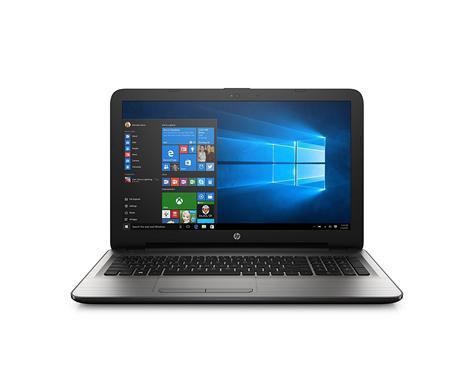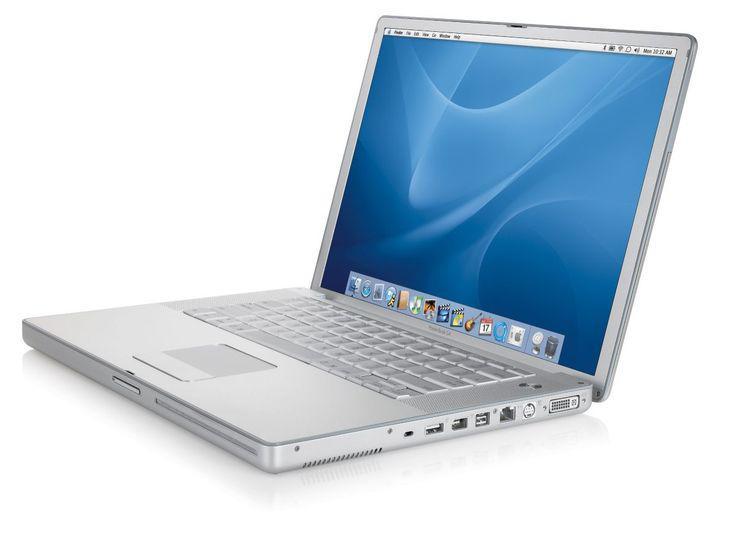The first image is the image on the left, the second image is the image on the right. Given the left and right images, does the statement "The right image contains a laptop with a kickstand propping the screen up." hold true? Answer yes or no. No. The first image is the image on the left, the second image is the image on the right. Evaluate the accuracy of this statement regarding the images: "The laptop on the left is displayed head-on, opened at least at a right angle, and the laptop on the right is displayed at an angle facing leftward.". Is it true? Answer yes or no. Yes. 